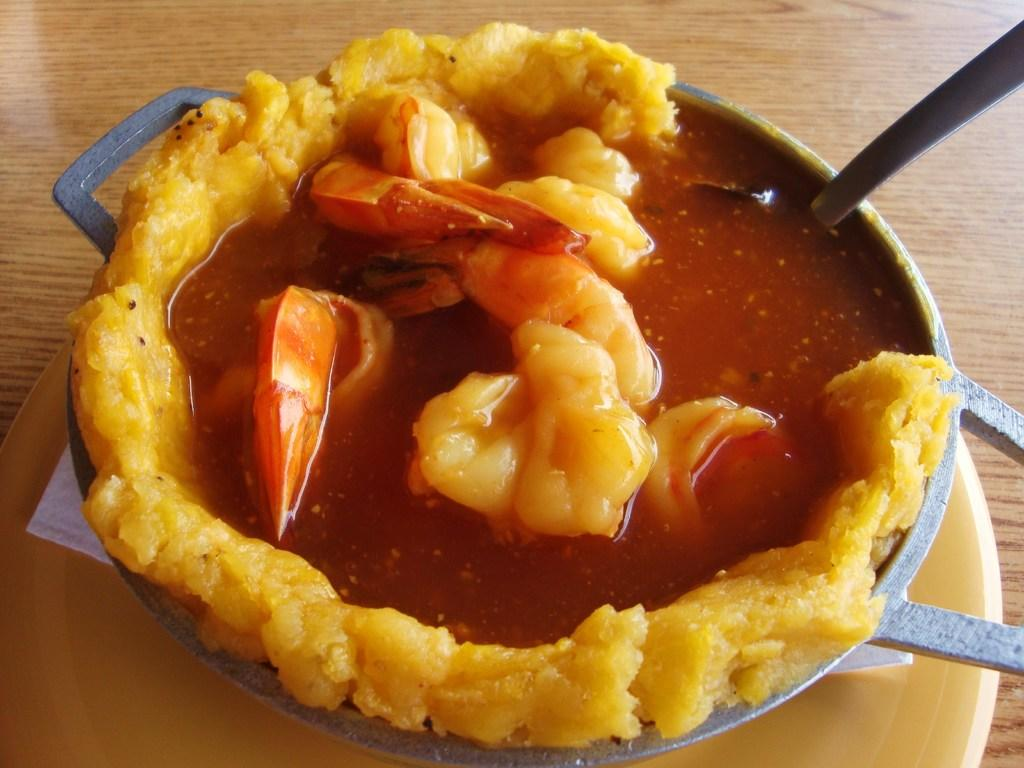What is being held in the utensil in the image? There is food in a utensil in the image. What type of utensil is visible in the image? There is a spoon in the image. Where is the plate located in the image? The plate is placed on a wooden surface in the image. What is used for cleaning or wiping in the image? There is tissue paper below the utensil in the image. What type of nerve can be seen in the image? There is no nerve present in the image. Is there a rock visible in the image? There is no rock visible in the image. 